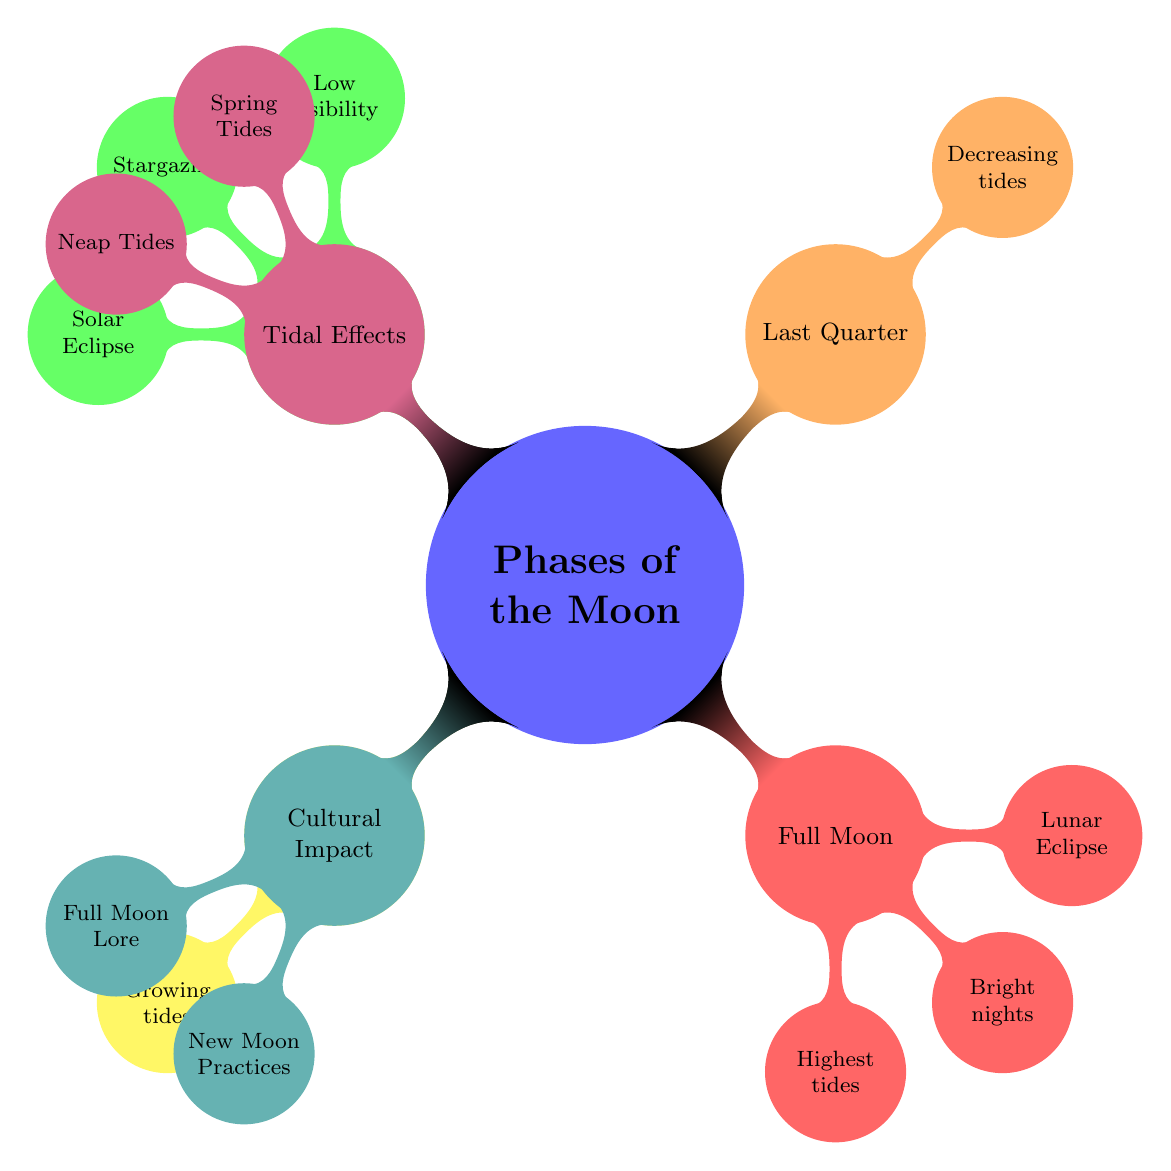What are the visible phases of the Moon in the diagram? The diagram shows four phases of the Moon: New Moon, First Quarter, Full Moon, and Last Quarter.
Answer: New Moon, First Quarter, Full Moon, Last Quarter What describes the New Moon phase? The description of the New Moon phase according to the diagram is "Moon is between Earth and Sun."
Answer: Moon is between Earth and Sun How many effects on Earth are listed for the Full Moon phase? The Full Moon phase has three effects listed: Highest tides, Bright illumination at night, and Potential impact on sleep.
Answer: 3 Which two phases are associated with Spring Tides? In the diagram, Spring Tides are associated with New Moon and Full Moon phases.
Answer: New Moon, Full Moon What is one cultural belief associated with the Full Moon? According to the diagram, one cultural belief associated with the Full Moon is "Increased lunacy."
Answer: Increased lunacy How does the visibility of the New Moon compare to the visibility of the Full Moon? The New Moon has low visibility at night, while the Full Moon has bright illumination at night, indicating that visibility is significantly higher during the Full Moon.
Answer: Low vs Bright Which moon phase is responsible for a Solar Eclipse? The diagram indicates that a Solar Eclipse occurs during the New Moon phase.
Answer: New Moon What type of tides occur during the First Quarter phase? According to the diagram, the First Quarter phase results in growing tidal forces.
Answer: Growing tidal forces How does the tide force change from the Last Quarter to the New Moon phase? From the Last Quarter, which has decreasing tidal forces, to the New Moon, which does not specify, it indicates a transition from lower to potentially higher tidal forces in the context of tidal effects.
Answer: Decreasing to potentially higher 